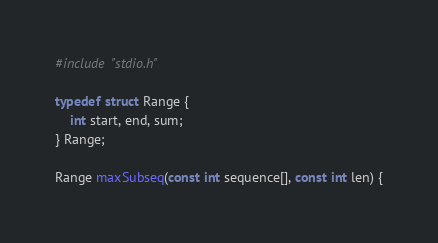Convert code to text. <code><loc_0><loc_0><loc_500><loc_500><_C_>#include "stdio.h"

typedef struct Range {
    int start, end, sum;
} Range;

Range maxSubseq(const int sequence[], const int len) {</code> 